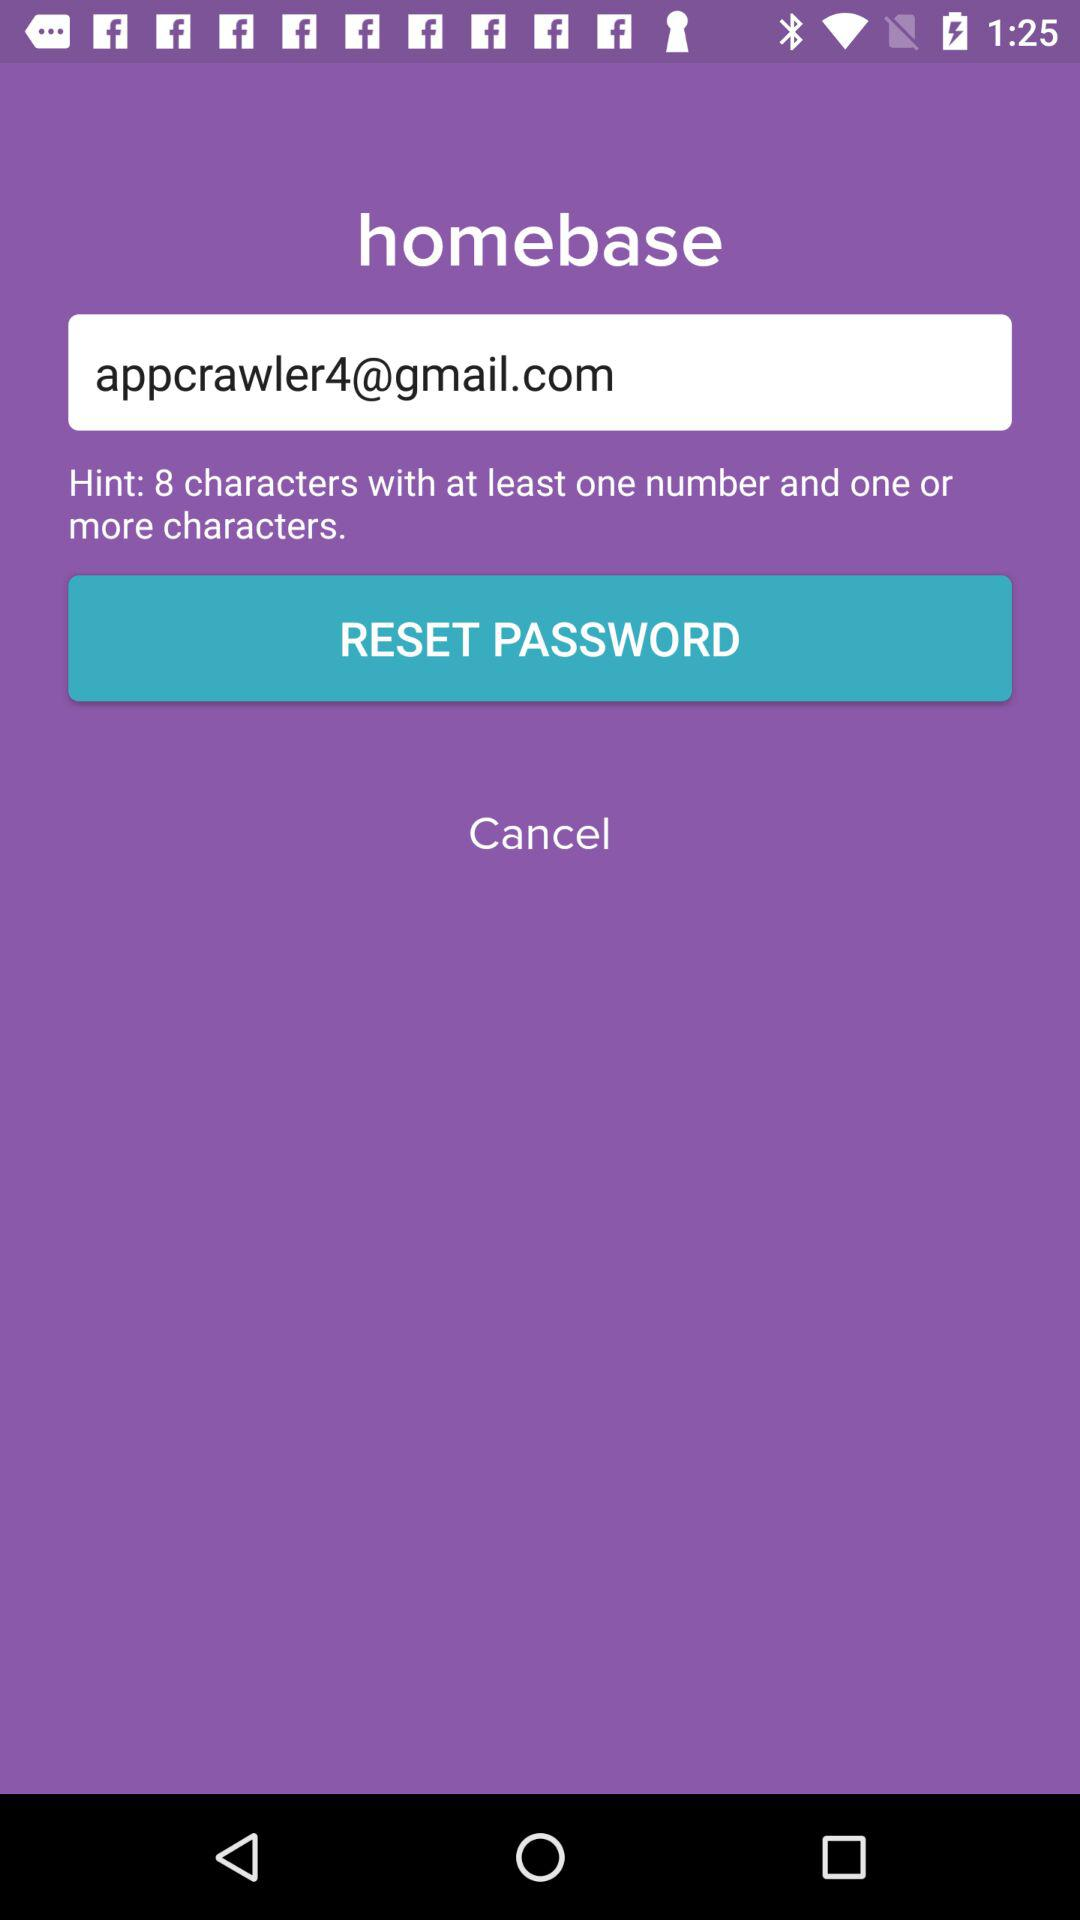What is the email address? The email address is appcrawler4@gmail.com. 